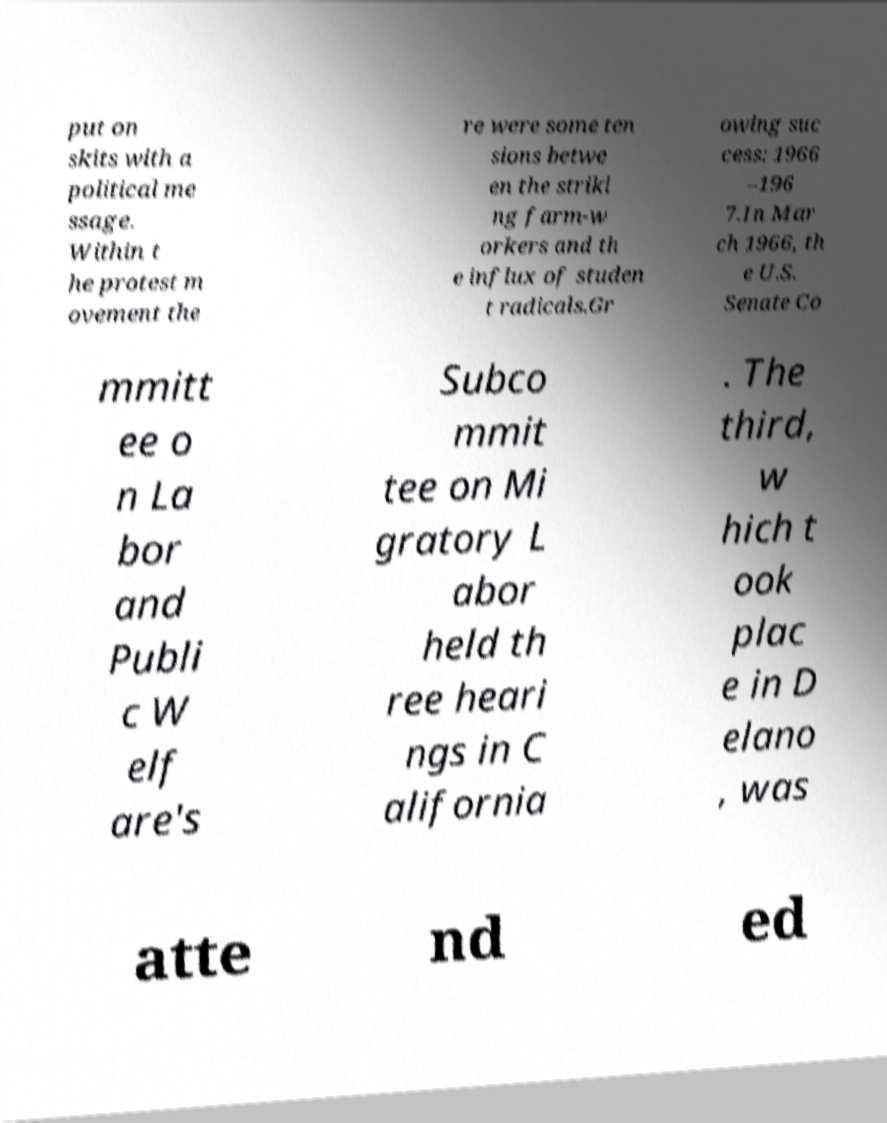Can you accurately transcribe the text from the provided image for me? put on skits with a political me ssage. Within t he protest m ovement the re were some ten sions betwe en the striki ng farm-w orkers and th e influx of studen t radicals.Gr owing suc cess: 1966 –196 7.In Mar ch 1966, th e U.S. Senate Co mmitt ee o n La bor and Publi c W elf are's Subco mmit tee on Mi gratory L abor held th ree heari ngs in C alifornia . The third, w hich t ook plac e in D elano , was atte nd ed 